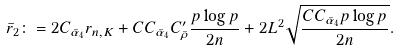Convert formula to latex. <formula><loc_0><loc_0><loc_500><loc_500>\bar { r } _ { 2 } \colon = 2 C _ { \bar { \alpha } _ { 4 } } r _ { n , K } + C C _ { \bar { \alpha } _ { 4 } } C _ { \bar { \rho } } ^ { \prime } \frac { p \log p } { 2 n } + 2 L ^ { 2 } \sqrt { \frac { C C _ { \bar { \alpha } _ { 4 } } p \log p } { 2 n } } .</formula> 